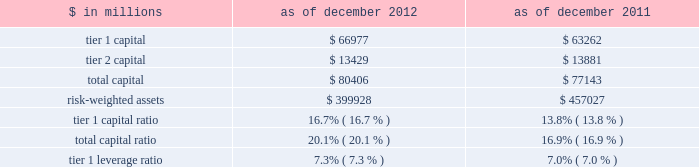Notes to consolidated financial statements note 20 .
Regulation and capital adequacy the federal reserve board is the primary regulator of group inc. , a bank holding company under the bank holding company act of 1956 ( bhc act ) and a financial holding company under amendments to the bhc act effected by the u.s .
Gramm-leach-bliley act of 1999 .
As a bank holding company , the firm is subject to consolidated regulatory capital requirements that are computed in accordance with the federal reserve board 2019s risk-based capital requirements ( which are based on the 2018basel 1 2019 capital accord of the basel committee ) .
These capital requirements are expressed as capital ratios that compare measures of capital to risk-weighted assets ( rwas ) .
The firm 2019s u.s .
Bank depository institution subsidiaries , including gs bank usa , are subject to similar capital requirements .
Under the federal reserve board 2019s capital adequacy requirements and the regulatory framework for prompt corrective action that is applicable to gs bank usa , the firm and its u.s .
Bank depository institution subsidiaries must meet specific capital requirements that involve quantitative measures of assets , liabilities and certain off- balance-sheet items as calculated under regulatory reporting practices .
The firm and its u.s .
Bank depository institution subsidiaries 2019 capital amounts , as well as gs bank usa 2019s prompt corrective action classification , are also subject to qualitative judgments by the regulators about components , risk weightings and other factors .
Many of the firm 2019s subsidiaries , including gs&co .
And the firm 2019s other broker-dealer subsidiaries , are subject to separate regulation and capital requirements as described below .
Group inc .
Federal reserve board regulations require bank holding companies to maintain a minimum tier 1 capital ratio of 4% ( 4 % ) and a minimum total capital ratio of 8% ( 8 % ) .
The required minimum tier 1 capital ratio and total capital ratio in order to be considered a 201cwell-capitalized 201d bank holding company under the federal reserve board guidelines are 6% ( 6 % ) and 10% ( 10 % ) , respectively .
Bank holding companies may be expected to maintain ratios well above the minimum levels , depending on their particular condition , risk profile and growth plans .
The minimum tier 1 leverage ratio is 3% ( 3 % ) for bank holding companies that have received the highest supervisory rating under federal reserve board guidelines or that have implemented the federal reserve board 2019s risk-based capital measure for market risk .
Other bank holding companies must have a minimum tier 1 leverage ratio of 4% ( 4 % ) .
The table below presents information regarding group inc . 2019s regulatory capital ratios. .
Rwas under the federal reserve board 2019s risk-based capital requirements are calculated based on the amount of market risk and credit risk .
Rwas for market risk are determined by reference to the firm 2019s value-at-risk ( var ) model , supplemented by other measures to capture risks not reflected in the firm 2019s var model .
Credit risk for on- balance sheet assets is based on the balance sheet value .
For off-balance sheet exposures , including otc derivatives and commitments , a credit equivalent amount is calculated based on the notional amount of each trade .
All such assets and exposures are then assigned a risk weight depending on , among other things , whether the counterparty is a sovereign , bank or a qualifying securities firm or other entity ( or if collateral is held , depending on the nature of the collateral ) .
Tier 1 leverage ratio is defined as tier 1 capital under basel 1 divided by average adjusted total assets ( which includes adjustments for disallowed goodwill and intangible assets , and the carrying value of equity investments in non-financial companies that are subject to deductions from tier 1 capital ) .
184 goldman sachs 2012 annual report .
As of december 2012 and 2011 in millions , what is the minimum total capital? 
Computations: table_min(total capital, none)
Answer: 77143.0. 